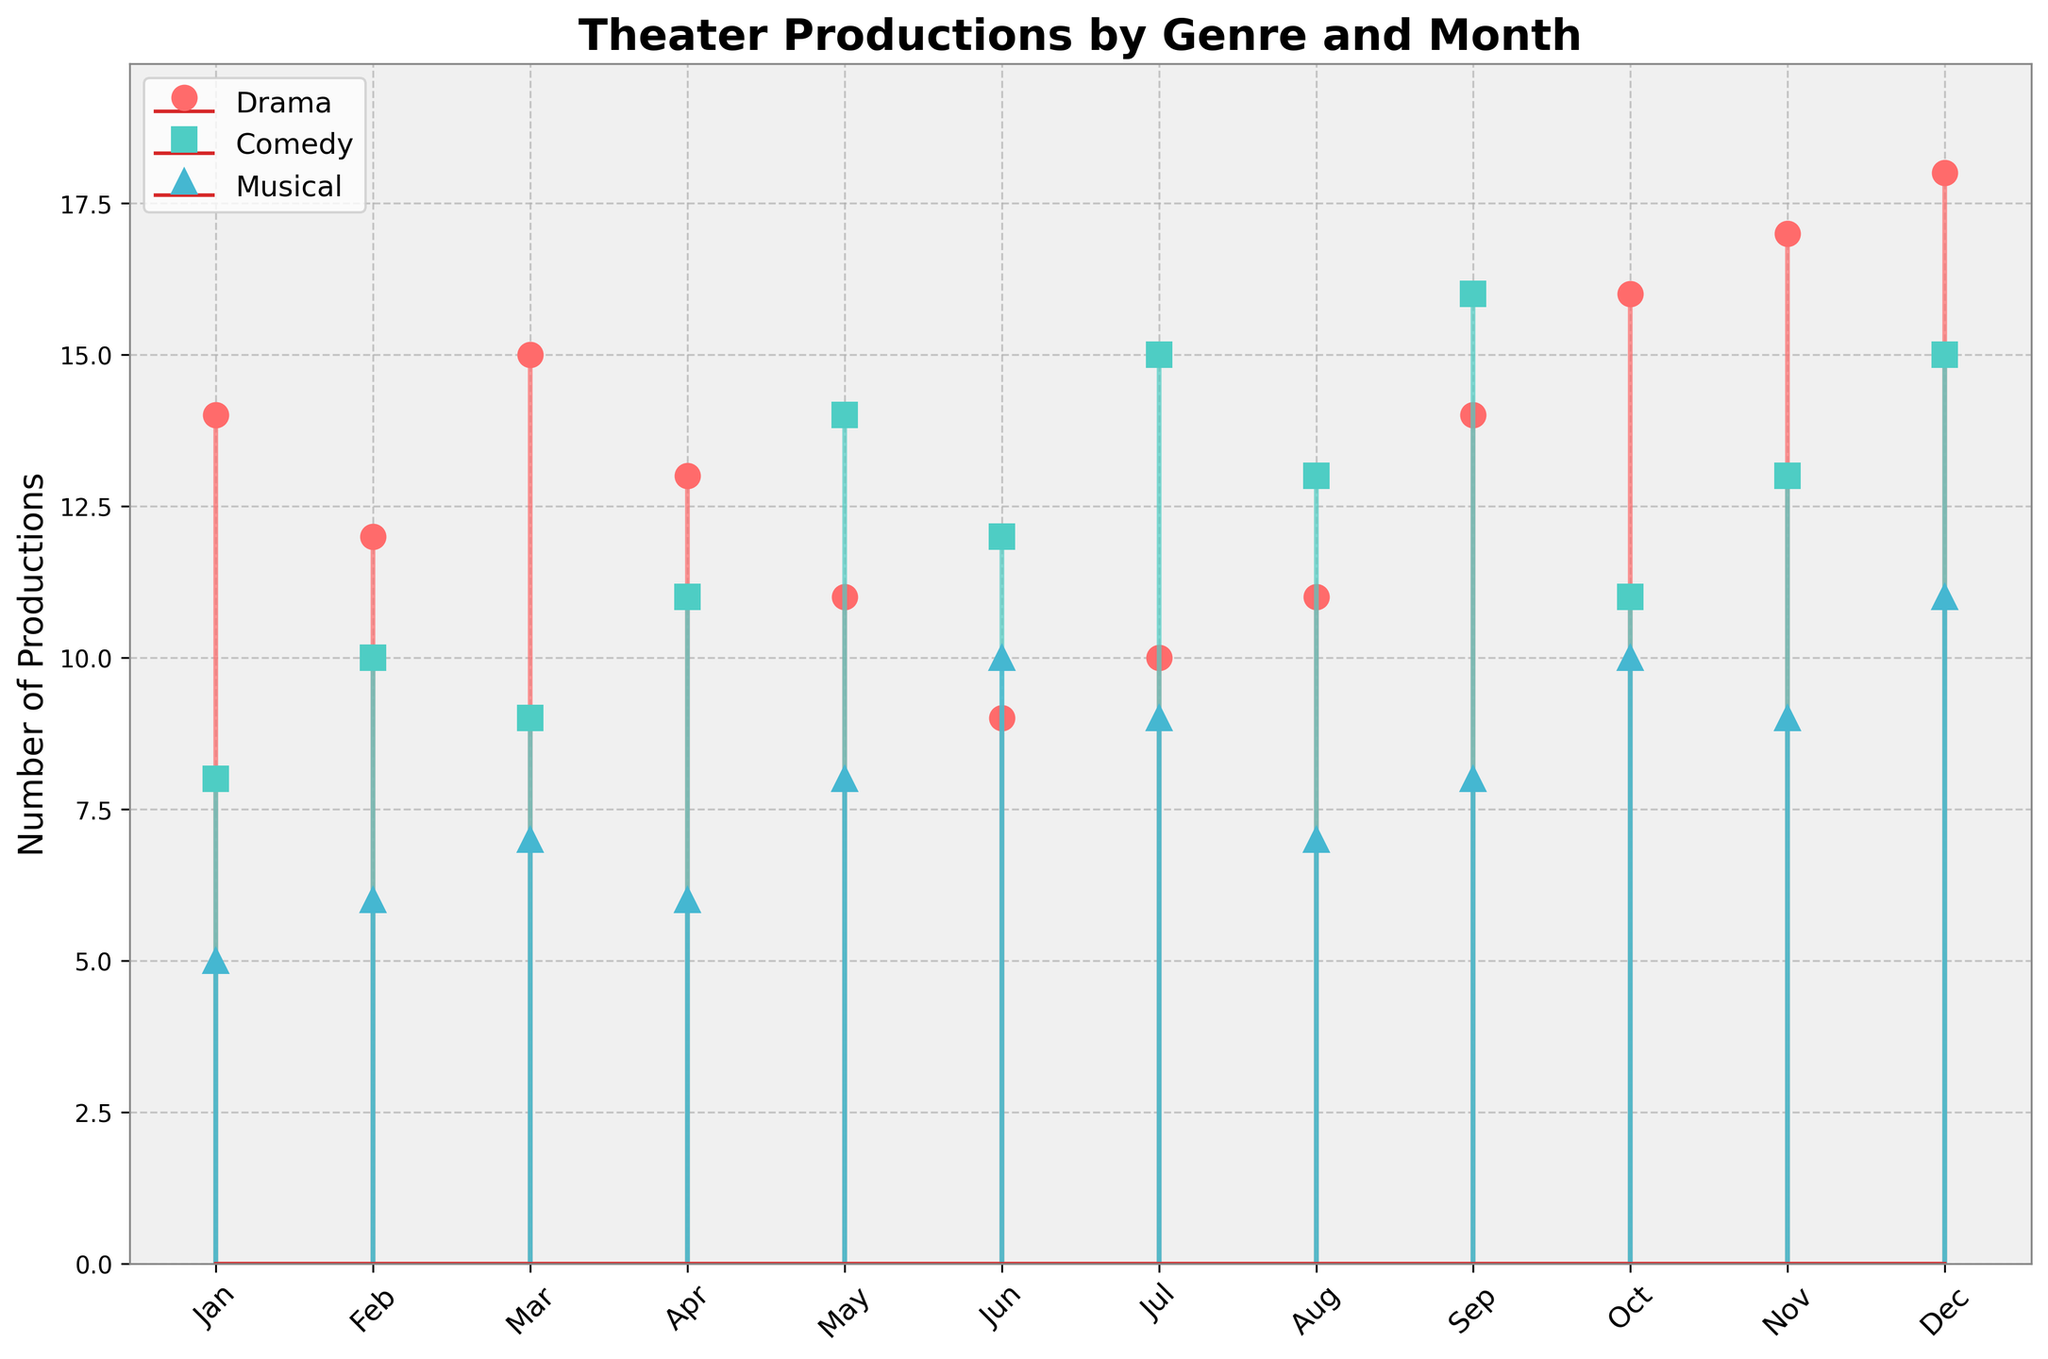What's the title of the figure? The title of the figure is displayed prominently at the top. It reads "Theater Productions by Genre and Month".
Answer: Theater Productions by Genre and Month What's the color used to represent drama productions? The drama productions are represented by red stems.
Answer: Red In which month are the maximum number of drama productions held? By looking at the stems with the red markers, the tallest red stem can be found in December.
Answer: December How many musical productions are there in October? The blue markers represent musical productions. In October, the blue stem reaches up to 10 on the y-axis.
Answer: 10 What's the average number of comedy productions in the first three months of the year? The number of comedy productions in January, February, and March are 8, 10, and 9, respectively. Sum these values: 8 + 10 + 9 = 27 and divide by 3.
Answer: 9 Compare the number of drama and comedy productions in July. Which one is higher? In July, the red stem for drama is at 10, and the green stem for comedy is at 15. Thus, comedy productions are higher.
Answer: Comedy Which genre has the most consistent number of productions throughout the year? By visually inspecting the stems for stability, the musical productions (blue markers) have less fluctuation compared to drama (red) and comedy (green).
Answer: Musical What is the total number of productions in May? Add the productions for each genre in May: Drama (11), Comedy (14), and Musical (8). So, 11 + 14 + 8 = 33.
Answer: 33 Which month experienced the highest total number of productions? Sum the productions for each genre and identify the month with the maximum sum. December has 18 (Drama) + 15 (Comedy) + 11 (Musical) = 44, which is the highest.
Answer: December How does the number of comedy productions in November compare to the number of drama productions in the same month? The green stem for comedy in November is at 13, and the red stem for drama is at 17. Drama productions are higher.
Answer: Drama 